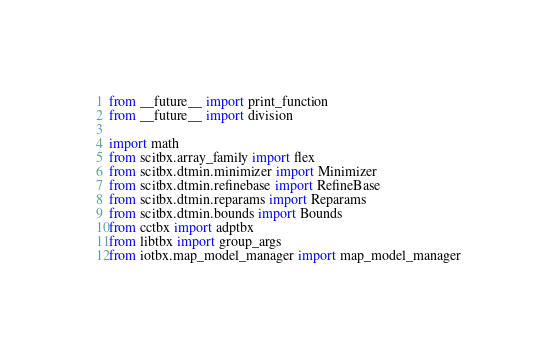Convert code to text. <code><loc_0><loc_0><loc_500><loc_500><_Python_>from __future__ import print_function
from __future__ import division

import math
from scitbx.array_family import flex
from scitbx.dtmin.minimizer import Minimizer
from scitbx.dtmin.refinebase import RefineBase
from scitbx.dtmin.reparams import Reparams
from scitbx.dtmin.bounds import Bounds
from cctbx import adptbx
from libtbx import group_args
from iotbx.map_model_manager import map_model_manager</code> 